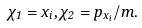<formula> <loc_0><loc_0><loc_500><loc_500>\chi _ { 1 } = x _ { i } , \chi _ { 2 } = p _ { x _ { i } } / m .</formula> 